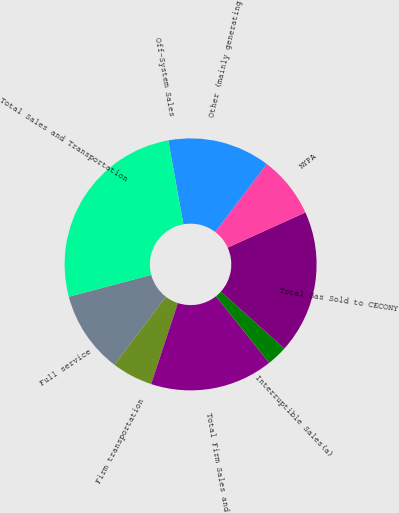Convert chart. <chart><loc_0><loc_0><loc_500><loc_500><pie_chart><fcel>Full service<fcel>Firm transportation<fcel>Total Firm Sales and<fcel>Interruptible Sales(a)<fcel>Total Gas Sold to CECONY<fcel>NYPA<fcel>Other (mainly generating<fcel>Off-System Sales<fcel>Total Sales and Transportation<nl><fcel>10.53%<fcel>5.27%<fcel>15.78%<fcel>2.64%<fcel>18.41%<fcel>7.9%<fcel>13.16%<fcel>0.02%<fcel>26.29%<nl></chart> 